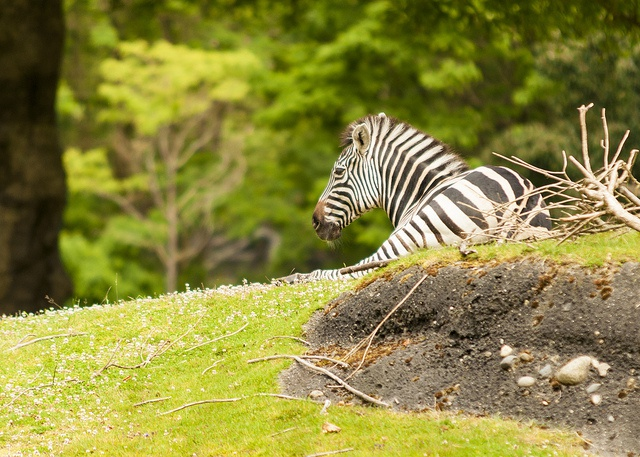Describe the objects in this image and their specific colors. I can see a zebra in black, ivory, gray, and tan tones in this image. 